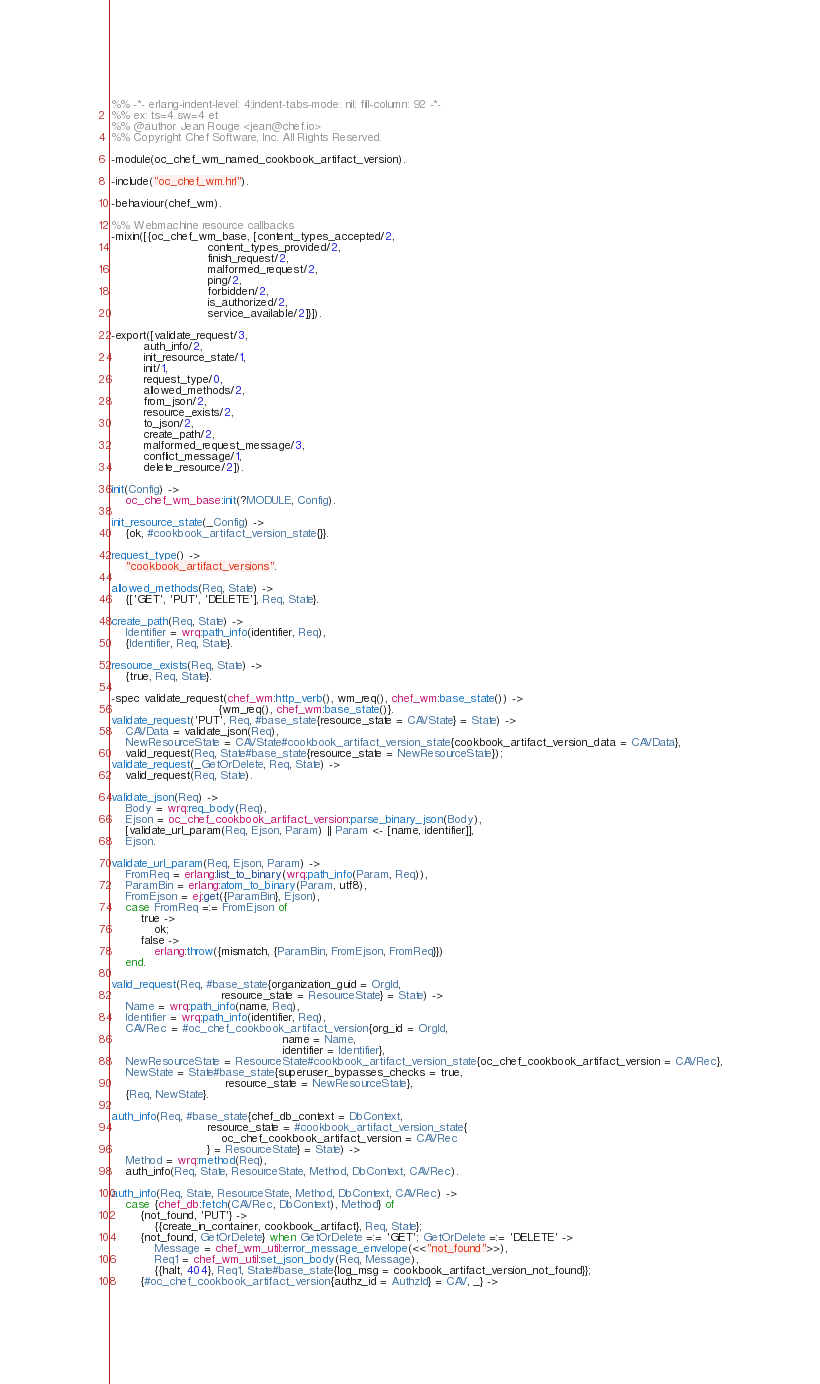<code> <loc_0><loc_0><loc_500><loc_500><_Erlang_>%% -*- erlang-indent-level: 4;indent-tabs-mode: nil; fill-column: 92 -*-
%% ex: ts=4 sw=4 et
%% @author Jean Rouge <jean@chef.io>
%% Copyright Chef Software, Inc. All Rights Reserved.

-module(oc_chef_wm_named_cookbook_artifact_version).

-include("oc_chef_wm.hrl").

-behaviour(chef_wm).

%% Webmachine resource callbacks
-mixin([{oc_chef_wm_base, [content_types_accepted/2,
                           content_types_provided/2,
                           finish_request/2,
                           malformed_request/2,
                           ping/2,
                           forbidden/2,
                           is_authorized/2,
                           service_available/2]}]).

-export([validate_request/3,
         auth_info/2,
         init_resource_state/1,
         init/1,
         request_type/0,
         allowed_methods/2,
         from_json/2,
         resource_exists/2,
         to_json/2,
         create_path/2,
         malformed_request_message/3,
         conflict_message/1,
         delete_resource/2]).

init(Config) ->
    oc_chef_wm_base:init(?MODULE, Config).

init_resource_state(_Config) ->
    {ok, #cookbook_artifact_version_state{}}.

request_type() ->
    "cookbook_artifact_versions".

allowed_methods(Req, State) ->
    {['GET', 'PUT', 'DELETE'], Req, State}.

create_path(Req, State) ->
    Identifier = wrq:path_info(identifier, Req),
    {Identifier, Req, State}.

resource_exists(Req, State) ->
    {true, Req, State}.

-spec validate_request(chef_wm:http_verb(), wm_req(), chef_wm:base_state()) ->
                              {wm_req(), chef_wm:base_state()}.
validate_request('PUT', Req, #base_state{resource_state = CAVState} = State) ->
    CAVData = validate_json(Req),
    NewResourceState = CAVState#cookbook_artifact_version_state{cookbook_artifact_version_data = CAVData},
    valid_request(Req, State#base_state{resource_state = NewResourceState});
validate_request(_GetOrDelete, Req, State) ->
    valid_request(Req, State).

validate_json(Req) ->
    Body = wrq:req_body(Req),
    Ejson = oc_chef_cookbook_artifact_version:parse_binary_json(Body),
    [validate_url_param(Req, Ejson, Param) || Param <- [name, identifier]],
    Ejson.

validate_url_param(Req, Ejson, Param) ->
    FromReq = erlang:list_to_binary(wrq:path_info(Param, Req)),
    ParamBin = erlang:atom_to_binary(Param, utf8),
    FromEjson = ej:get({ParamBin}, Ejson),
    case FromReq =:= FromEjson of
        true ->
            ok;
        false ->
            erlang:throw({mismatch, {ParamBin, FromEjson, FromReq}})
    end.

valid_request(Req, #base_state{organization_guid = OrgId,
                               resource_state = ResourceState} = State) ->
    Name = wrq:path_info(name, Req),
    Identifier = wrq:path_info(identifier, Req),
    CAVRec = #oc_chef_cookbook_artifact_version{org_id = OrgId,
                                                name = Name,
                                                identifier = Identifier},
    NewResourceState = ResourceState#cookbook_artifact_version_state{oc_chef_cookbook_artifact_version = CAVRec},
    NewState = State#base_state{superuser_bypasses_checks = true,
                                resource_state = NewResourceState},
    {Req, NewState}.

auth_info(Req, #base_state{chef_db_context = DbContext,
                           resource_state = #cookbook_artifact_version_state{
                               oc_chef_cookbook_artifact_version = CAVRec
                           } = ResourceState} = State) ->
    Method = wrq:method(Req),
    auth_info(Req, State, ResourceState, Method, DbContext, CAVRec).

auth_info(Req, State, ResourceState, Method, DbContext, CAVRec) ->
    case {chef_db:fetch(CAVRec, DbContext), Method} of
        {not_found, 'PUT'} ->
            {{create_in_container, cookbook_artifact}, Req, State};
        {not_found, GetOrDelete} when GetOrDelete =:= 'GET'; GetOrDelete =:= 'DELETE' ->
            Message = chef_wm_util:error_message_envelope(<<"not_found">>),
            Req1 = chef_wm_util:set_json_body(Req, Message),
            {{halt, 404}, Req1, State#base_state{log_msg = cookbook_artifact_version_not_found}};
        {#oc_chef_cookbook_artifact_version{authz_id = AuthzId} = CAV, _} -></code> 